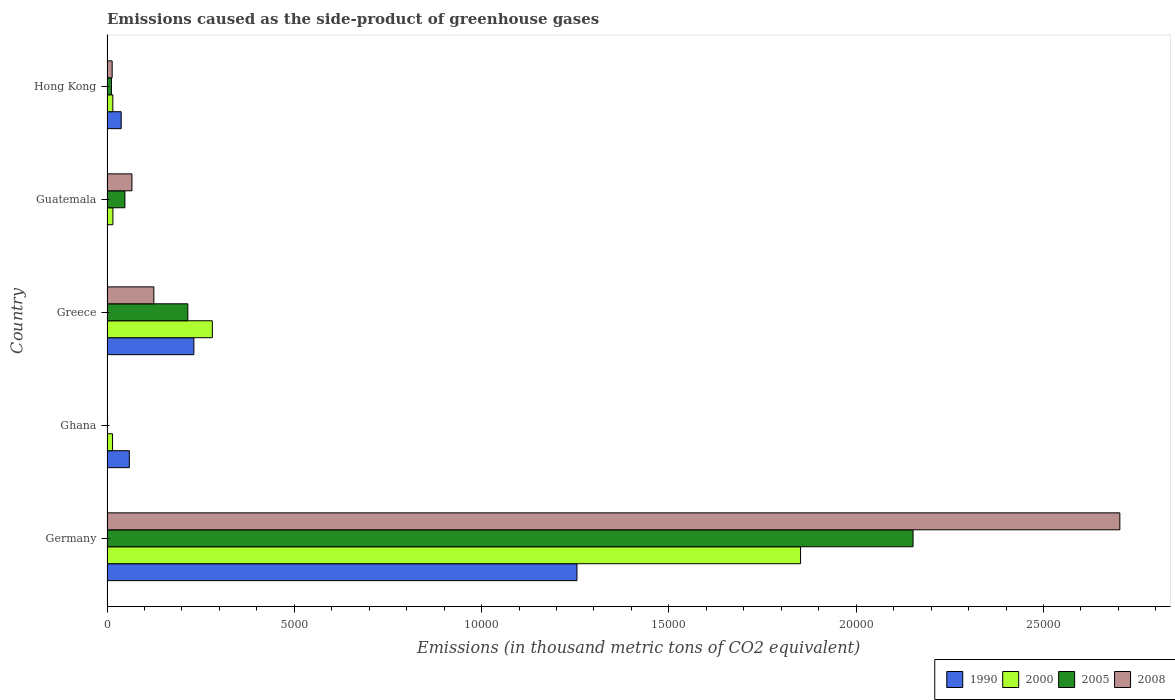How many groups of bars are there?
Give a very brief answer. 5. Are the number of bars on each tick of the Y-axis equal?
Ensure brevity in your answer.  Yes. How many bars are there on the 5th tick from the top?
Ensure brevity in your answer.  4. How many bars are there on the 4th tick from the bottom?
Make the answer very short. 4. What is the label of the 3rd group of bars from the top?
Offer a very short reply. Greece. What is the emissions caused as the side-product of greenhouse gases in 2005 in Hong Kong?
Make the answer very short. 119. Across all countries, what is the maximum emissions caused as the side-product of greenhouse gases in 2008?
Offer a terse response. 2.70e+04. In which country was the emissions caused as the side-product of greenhouse gases in 2008 minimum?
Offer a terse response. Ghana. What is the total emissions caused as the side-product of greenhouse gases in 2000 in the graph?
Make the answer very short. 2.18e+04. What is the difference between the emissions caused as the side-product of greenhouse gases in 2000 in Germany and that in Ghana?
Provide a succinct answer. 1.84e+04. What is the difference between the emissions caused as the side-product of greenhouse gases in 2000 in Guatemala and the emissions caused as the side-product of greenhouse gases in 2008 in Germany?
Provide a short and direct response. -2.69e+04. What is the average emissions caused as the side-product of greenhouse gases in 2005 per country?
Your response must be concise. 4857.2. What is the difference between the emissions caused as the side-product of greenhouse gases in 2005 and emissions caused as the side-product of greenhouse gases in 2008 in Guatemala?
Offer a terse response. -188. In how many countries, is the emissions caused as the side-product of greenhouse gases in 2008 greater than 1000 thousand metric tons?
Offer a terse response. 2. What is the ratio of the emissions caused as the side-product of greenhouse gases in 1990 in Greece to that in Guatemala?
Make the answer very short. 2.32e+04. Is the difference between the emissions caused as the side-product of greenhouse gases in 2005 in Germany and Guatemala greater than the difference between the emissions caused as the side-product of greenhouse gases in 2008 in Germany and Guatemala?
Offer a very short reply. No. What is the difference between the highest and the second highest emissions caused as the side-product of greenhouse gases in 2000?
Your answer should be compact. 1.57e+04. What is the difference between the highest and the lowest emissions caused as the side-product of greenhouse gases in 1990?
Ensure brevity in your answer.  1.25e+04. In how many countries, is the emissions caused as the side-product of greenhouse gases in 1990 greater than the average emissions caused as the side-product of greenhouse gases in 1990 taken over all countries?
Your answer should be compact. 1. Is it the case that in every country, the sum of the emissions caused as the side-product of greenhouse gases in 1990 and emissions caused as the side-product of greenhouse gases in 2005 is greater than the sum of emissions caused as the side-product of greenhouse gases in 2000 and emissions caused as the side-product of greenhouse gases in 2008?
Provide a succinct answer. No. What does the 2nd bar from the top in Ghana represents?
Your answer should be very brief. 2005. What does the 3rd bar from the bottom in Greece represents?
Give a very brief answer. 2005. How many bars are there?
Give a very brief answer. 20. Are all the bars in the graph horizontal?
Your answer should be very brief. Yes. Are the values on the major ticks of X-axis written in scientific E-notation?
Keep it short and to the point. No. Does the graph contain any zero values?
Ensure brevity in your answer.  No. Does the graph contain grids?
Your answer should be very brief. No. What is the title of the graph?
Offer a terse response. Emissions caused as the side-product of greenhouse gases. What is the label or title of the X-axis?
Make the answer very short. Emissions (in thousand metric tons of CO2 equivalent). What is the label or title of the Y-axis?
Offer a very short reply. Country. What is the Emissions (in thousand metric tons of CO2 equivalent) in 1990 in Germany?
Your answer should be compact. 1.25e+04. What is the Emissions (in thousand metric tons of CO2 equivalent) of 2000 in Germany?
Give a very brief answer. 1.85e+04. What is the Emissions (in thousand metric tons of CO2 equivalent) in 2005 in Germany?
Your answer should be very brief. 2.15e+04. What is the Emissions (in thousand metric tons of CO2 equivalent) of 2008 in Germany?
Make the answer very short. 2.70e+04. What is the Emissions (in thousand metric tons of CO2 equivalent) in 1990 in Ghana?
Give a very brief answer. 596.2. What is the Emissions (in thousand metric tons of CO2 equivalent) in 2000 in Ghana?
Make the answer very short. 148. What is the Emissions (in thousand metric tons of CO2 equivalent) in 2008 in Ghana?
Offer a terse response. 11.2. What is the Emissions (in thousand metric tons of CO2 equivalent) of 1990 in Greece?
Make the answer very short. 2318.5. What is the Emissions (in thousand metric tons of CO2 equivalent) of 2000 in Greece?
Your answer should be very brief. 2811.5. What is the Emissions (in thousand metric tons of CO2 equivalent) in 2005 in Greece?
Provide a short and direct response. 2157. What is the Emissions (in thousand metric tons of CO2 equivalent) in 2008 in Greece?
Provide a short and direct response. 1250.2. What is the Emissions (in thousand metric tons of CO2 equivalent) of 2000 in Guatemala?
Offer a terse response. 157.6. What is the Emissions (in thousand metric tons of CO2 equivalent) of 2005 in Guatemala?
Ensure brevity in your answer.  477.8. What is the Emissions (in thousand metric tons of CO2 equivalent) in 2008 in Guatemala?
Provide a succinct answer. 665.8. What is the Emissions (in thousand metric tons of CO2 equivalent) of 1990 in Hong Kong?
Your answer should be very brief. 379. What is the Emissions (in thousand metric tons of CO2 equivalent) of 2000 in Hong Kong?
Give a very brief answer. 155.3. What is the Emissions (in thousand metric tons of CO2 equivalent) in 2005 in Hong Kong?
Provide a succinct answer. 119. What is the Emissions (in thousand metric tons of CO2 equivalent) in 2008 in Hong Kong?
Give a very brief answer. 137.4. Across all countries, what is the maximum Emissions (in thousand metric tons of CO2 equivalent) of 1990?
Offer a terse response. 1.25e+04. Across all countries, what is the maximum Emissions (in thousand metric tons of CO2 equivalent) of 2000?
Ensure brevity in your answer.  1.85e+04. Across all countries, what is the maximum Emissions (in thousand metric tons of CO2 equivalent) in 2005?
Provide a short and direct response. 2.15e+04. Across all countries, what is the maximum Emissions (in thousand metric tons of CO2 equivalent) in 2008?
Give a very brief answer. 2.70e+04. Across all countries, what is the minimum Emissions (in thousand metric tons of CO2 equivalent) of 1990?
Provide a short and direct response. 0.1. Across all countries, what is the minimum Emissions (in thousand metric tons of CO2 equivalent) in 2000?
Your answer should be compact. 148. What is the total Emissions (in thousand metric tons of CO2 equivalent) in 1990 in the graph?
Offer a very short reply. 1.58e+04. What is the total Emissions (in thousand metric tons of CO2 equivalent) in 2000 in the graph?
Your answer should be very brief. 2.18e+04. What is the total Emissions (in thousand metric tons of CO2 equivalent) in 2005 in the graph?
Offer a very short reply. 2.43e+04. What is the total Emissions (in thousand metric tons of CO2 equivalent) of 2008 in the graph?
Ensure brevity in your answer.  2.91e+04. What is the difference between the Emissions (in thousand metric tons of CO2 equivalent) in 1990 in Germany and that in Ghana?
Give a very brief answer. 1.19e+04. What is the difference between the Emissions (in thousand metric tons of CO2 equivalent) in 2000 in Germany and that in Ghana?
Your answer should be compact. 1.84e+04. What is the difference between the Emissions (in thousand metric tons of CO2 equivalent) of 2005 in Germany and that in Ghana?
Your answer should be compact. 2.15e+04. What is the difference between the Emissions (in thousand metric tons of CO2 equivalent) of 2008 in Germany and that in Ghana?
Provide a succinct answer. 2.70e+04. What is the difference between the Emissions (in thousand metric tons of CO2 equivalent) in 1990 in Germany and that in Greece?
Your answer should be compact. 1.02e+04. What is the difference between the Emissions (in thousand metric tons of CO2 equivalent) of 2000 in Germany and that in Greece?
Provide a succinct answer. 1.57e+04. What is the difference between the Emissions (in thousand metric tons of CO2 equivalent) of 2005 in Germany and that in Greece?
Make the answer very short. 1.94e+04. What is the difference between the Emissions (in thousand metric tons of CO2 equivalent) in 2008 in Germany and that in Greece?
Provide a succinct answer. 2.58e+04. What is the difference between the Emissions (in thousand metric tons of CO2 equivalent) of 1990 in Germany and that in Guatemala?
Your answer should be very brief. 1.25e+04. What is the difference between the Emissions (in thousand metric tons of CO2 equivalent) of 2000 in Germany and that in Guatemala?
Provide a succinct answer. 1.84e+04. What is the difference between the Emissions (in thousand metric tons of CO2 equivalent) of 2005 in Germany and that in Guatemala?
Offer a very short reply. 2.10e+04. What is the difference between the Emissions (in thousand metric tons of CO2 equivalent) in 2008 in Germany and that in Guatemala?
Your response must be concise. 2.64e+04. What is the difference between the Emissions (in thousand metric tons of CO2 equivalent) in 1990 in Germany and that in Hong Kong?
Make the answer very short. 1.22e+04. What is the difference between the Emissions (in thousand metric tons of CO2 equivalent) in 2000 in Germany and that in Hong Kong?
Your answer should be compact. 1.84e+04. What is the difference between the Emissions (in thousand metric tons of CO2 equivalent) in 2005 in Germany and that in Hong Kong?
Your answer should be compact. 2.14e+04. What is the difference between the Emissions (in thousand metric tons of CO2 equivalent) in 2008 in Germany and that in Hong Kong?
Make the answer very short. 2.69e+04. What is the difference between the Emissions (in thousand metric tons of CO2 equivalent) in 1990 in Ghana and that in Greece?
Provide a short and direct response. -1722.3. What is the difference between the Emissions (in thousand metric tons of CO2 equivalent) of 2000 in Ghana and that in Greece?
Keep it short and to the point. -2663.5. What is the difference between the Emissions (in thousand metric tons of CO2 equivalent) of 2005 in Ghana and that in Greece?
Provide a succinct answer. -2142.3. What is the difference between the Emissions (in thousand metric tons of CO2 equivalent) of 2008 in Ghana and that in Greece?
Your answer should be very brief. -1239. What is the difference between the Emissions (in thousand metric tons of CO2 equivalent) in 1990 in Ghana and that in Guatemala?
Ensure brevity in your answer.  596.1. What is the difference between the Emissions (in thousand metric tons of CO2 equivalent) in 2005 in Ghana and that in Guatemala?
Your answer should be very brief. -463.1. What is the difference between the Emissions (in thousand metric tons of CO2 equivalent) in 2008 in Ghana and that in Guatemala?
Provide a succinct answer. -654.6. What is the difference between the Emissions (in thousand metric tons of CO2 equivalent) in 1990 in Ghana and that in Hong Kong?
Ensure brevity in your answer.  217.2. What is the difference between the Emissions (in thousand metric tons of CO2 equivalent) of 2005 in Ghana and that in Hong Kong?
Your answer should be compact. -104.3. What is the difference between the Emissions (in thousand metric tons of CO2 equivalent) in 2008 in Ghana and that in Hong Kong?
Your response must be concise. -126.2. What is the difference between the Emissions (in thousand metric tons of CO2 equivalent) of 1990 in Greece and that in Guatemala?
Offer a very short reply. 2318.4. What is the difference between the Emissions (in thousand metric tons of CO2 equivalent) of 2000 in Greece and that in Guatemala?
Keep it short and to the point. 2653.9. What is the difference between the Emissions (in thousand metric tons of CO2 equivalent) of 2005 in Greece and that in Guatemala?
Ensure brevity in your answer.  1679.2. What is the difference between the Emissions (in thousand metric tons of CO2 equivalent) in 2008 in Greece and that in Guatemala?
Make the answer very short. 584.4. What is the difference between the Emissions (in thousand metric tons of CO2 equivalent) of 1990 in Greece and that in Hong Kong?
Your answer should be very brief. 1939.5. What is the difference between the Emissions (in thousand metric tons of CO2 equivalent) of 2000 in Greece and that in Hong Kong?
Make the answer very short. 2656.2. What is the difference between the Emissions (in thousand metric tons of CO2 equivalent) of 2005 in Greece and that in Hong Kong?
Keep it short and to the point. 2038. What is the difference between the Emissions (in thousand metric tons of CO2 equivalent) of 2008 in Greece and that in Hong Kong?
Your answer should be very brief. 1112.8. What is the difference between the Emissions (in thousand metric tons of CO2 equivalent) in 1990 in Guatemala and that in Hong Kong?
Your response must be concise. -378.9. What is the difference between the Emissions (in thousand metric tons of CO2 equivalent) of 2005 in Guatemala and that in Hong Kong?
Provide a succinct answer. 358.8. What is the difference between the Emissions (in thousand metric tons of CO2 equivalent) of 2008 in Guatemala and that in Hong Kong?
Provide a short and direct response. 528.4. What is the difference between the Emissions (in thousand metric tons of CO2 equivalent) in 1990 in Germany and the Emissions (in thousand metric tons of CO2 equivalent) in 2000 in Ghana?
Give a very brief answer. 1.24e+04. What is the difference between the Emissions (in thousand metric tons of CO2 equivalent) of 1990 in Germany and the Emissions (in thousand metric tons of CO2 equivalent) of 2005 in Ghana?
Your answer should be very brief. 1.25e+04. What is the difference between the Emissions (in thousand metric tons of CO2 equivalent) of 1990 in Germany and the Emissions (in thousand metric tons of CO2 equivalent) of 2008 in Ghana?
Your answer should be very brief. 1.25e+04. What is the difference between the Emissions (in thousand metric tons of CO2 equivalent) of 2000 in Germany and the Emissions (in thousand metric tons of CO2 equivalent) of 2005 in Ghana?
Give a very brief answer. 1.85e+04. What is the difference between the Emissions (in thousand metric tons of CO2 equivalent) in 2000 in Germany and the Emissions (in thousand metric tons of CO2 equivalent) in 2008 in Ghana?
Your answer should be compact. 1.85e+04. What is the difference between the Emissions (in thousand metric tons of CO2 equivalent) in 2005 in Germany and the Emissions (in thousand metric tons of CO2 equivalent) in 2008 in Ghana?
Provide a succinct answer. 2.15e+04. What is the difference between the Emissions (in thousand metric tons of CO2 equivalent) of 1990 in Germany and the Emissions (in thousand metric tons of CO2 equivalent) of 2000 in Greece?
Provide a succinct answer. 9734.2. What is the difference between the Emissions (in thousand metric tons of CO2 equivalent) in 1990 in Germany and the Emissions (in thousand metric tons of CO2 equivalent) in 2005 in Greece?
Ensure brevity in your answer.  1.04e+04. What is the difference between the Emissions (in thousand metric tons of CO2 equivalent) of 1990 in Germany and the Emissions (in thousand metric tons of CO2 equivalent) of 2008 in Greece?
Your response must be concise. 1.13e+04. What is the difference between the Emissions (in thousand metric tons of CO2 equivalent) of 2000 in Germany and the Emissions (in thousand metric tons of CO2 equivalent) of 2005 in Greece?
Your answer should be compact. 1.64e+04. What is the difference between the Emissions (in thousand metric tons of CO2 equivalent) in 2000 in Germany and the Emissions (in thousand metric tons of CO2 equivalent) in 2008 in Greece?
Keep it short and to the point. 1.73e+04. What is the difference between the Emissions (in thousand metric tons of CO2 equivalent) in 2005 in Germany and the Emissions (in thousand metric tons of CO2 equivalent) in 2008 in Greece?
Offer a terse response. 2.03e+04. What is the difference between the Emissions (in thousand metric tons of CO2 equivalent) of 1990 in Germany and the Emissions (in thousand metric tons of CO2 equivalent) of 2000 in Guatemala?
Make the answer very short. 1.24e+04. What is the difference between the Emissions (in thousand metric tons of CO2 equivalent) in 1990 in Germany and the Emissions (in thousand metric tons of CO2 equivalent) in 2005 in Guatemala?
Provide a short and direct response. 1.21e+04. What is the difference between the Emissions (in thousand metric tons of CO2 equivalent) of 1990 in Germany and the Emissions (in thousand metric tons of CO2 equivalent) of 2008 in Guatemala?
Your response must be concise. 1.19e+04. What is the difference between the Emissions (in thousand metric tons of CO2 equivalent) in 2000 in Germany and the Emissions (in thousand metric tons of CO2 equivalent) in 2005 in Guatemala?
Your response must be concise. 1.80e+04. What is the difference between the Emissions (in thousand metric tons of CO2 equivalent) in 2000 in Germany and the Emissions (in thousand metric tons of CO2 equivalent) in 2008 in Guatemala?
Ensure brevity in your answer.  1.78e+04. What is the difference between the Emissions (in thousand metric tons of CO2 equivalent) of 2005 in Germany and the Emissions (in thousand metric tons of CO2 equivalent) of 2008 in Guatemala?
Your answer should be very brief. 2.09e+04. What is the difference between the Emissions (in thousand metric tons of CO2 equivalent) of 1990 in Germany and the Emissions (in thousand metric tons of CO2 equivalent) of 2000 in Hong Kong?
Your response must be concise. 1.24e+04. What is the difference between the Emissions (in thousand metric tons of CO2 equivalent) in 1990 in Germany and the Emissions (in thousand metric tons of CO2 equivalent) in 2005 in Hong Kong?
Keep it short and to the point. 1.24e+04. What is the difference between the Emissions (in thousand metric tons of CO2 equivalent) of 1990 in Germany and the Emissions (in thousand metric tons of CO2 equivalent) of 2008 in Hong Kong?
Keep it short and to the point. 1.24e+04. What is the difference between the Emissions (in thousand metric tons of CO2 equivalent) of 2000 in Germany and the Emissions (in thousand metric tons of CO2 equivalent) of 2005 in Hong Kong?
Provide a succinct answer. 1.84e+04. What is the difference between the Emissions (in thousand metric tons of CO2 equivalent) in 2000 in Germany and the Emissions (in thousand metric tons of CO2 equivalent) in 2008 in Hong Kong?
Offer a very short reply. 1.84e+04. What is the difference between the Emissions (in thousand metric tons of CO2 equivalent) of 2005 in Germany and the Emissions (in thousand metric tons of CO2 equivalent) of 2008 in Hong Kong?
Provide a short and direct response. 2.14e+04. What is the difference between the Emissions (in thousand metric tons of CO2 equivalent) of 1990 in Ghana and the Emissions (in thousand metric tons of CO2 equivalent) of 2000 in Greece?
Ensure brevity in your answer.  -2215.3. What is the difference between the Emissions (in thousand metric tons of CO2 equivalent) in 1990 in Ghana and the Emissions (in thousand metric tons of CO2 equivalent) in 2005 in Greece?
Offer a very short reply. -1560.8. What is the difference between the Emissions (in thousand metric tons of CO2 equivalent) of 1990 in Ghana and the Emissions (in thousand metric tons of CO2 equivalent) of 2008 in Greece?
Your answer should be compact. -654. What is the difference between the Emissions (in thousand metric tons of CO2 equivalent) of 2000 in Ghana and the Emissions (in thousand metric tons of CO2 equivalent) of 2005 in Greece?
Ensure brevity in your answer.  -2009. What is the difference between the Emissions (in thousand metric tons of CO2 equivalent) in 2000 in Ghana and the Emissions (in thousand metric tons of CO2 equivalent) in 2008 in Greece?
Provide a succinct answer. -1102.2. What is the difference between the Emissions (in thousand metric tons of CO2 equivalent) of 2005 in Ghana and the Emissions (in thousand metric tons of CO2 equivalent) of 2008 in Greece?
Provide a short and direct response. -1235.5. What is the difference between the Emissions (in thousand metric tons of CO2 equivalent) of 1990 in Ghana and the Emissions (in thousand metric tons of CO2 equivalent) of 2000 in Guatemala?
Provide a succinct answer. 438.6. What is the difference between the Emissions (in thousand metric tons of CO2 equivalent) in 1990 in Ghana and the Emissions (in thousand metric tons of CO2 equivalent) in 2005 in Guatemala?
Your response must be concise. 118.4. What is the difference between the Emissions (in thousand metric tons of CO2 equivalent) of 1990 in Ghana and the Emissions (in thousand metric tons of CO2 equivalent) of 2008 in Guatemala?
Provide a short and direct response. -69.6. What is the difference between the Emissions (in thousand metric tons of CO2 equivalent) in 2000 in Ghana and the Emissions (in thousand metric tons of CO2 equivalent) in 2005 in Guatemala?
Provide a succinct answer. -329.8. What is the difference between the Emissions (in thousand metric tons of CO2 equivalent) of 2000 in Ghana and the Emissions (in thousand metric tons of CO2 equivalent) of 2008 in Guatemala?
Make the answer very short. -517.8. What is the difference between the Emissions (in thousand metric tons of CO2 equivalent) of 2005 in Ghana and the Emissions (in thousand metric tons of CO2 equivalent) of 2008 in Guatemala?
Provide a succinct answer. -651.1. What is the difference between the Emissions (in thousand metric tons of CO2 equivalent) in 1990 in Ghana and the Emissions (in thousand metric tons of CO2 equivalent) in 2000 in Hong Kong?
Ensure brevity in your answer.  440.9. What is the difference between the Emissions (in thousand metric tons of CO2 equivalent) in 1990 in Ghana and the Emissions (in thousand metric tons of CO2 equivalent) in 2005 in Hong Kong?
Your answer should be very brief. 477.2. What is the difference between the Emissions (in thousand metric tons of CO2 equivalent) in 1990 in Ghana and the Emissions (in thousand metric tons of CO2 equivalent) in 2008 in Hong Kong?
Offer a very short reply. 458.8. What is the difference between the Emissions (in thousand metric tons of CO2 equivalent) of 2000 in Ghana and the Emissions (in thousand metric tons of CO2 equivalent) of 2005 in Hong Kong?
Make the answer very short. 29. What is the difference between the Emissions (in thousand metric tons of CO2 equivalent) of 2005 in Ghana and the Emissions (in thousand metric tons of CO2 equivalent) of 2008 in Hong Kong?
Provide a succinct answer. -122.7. What is the difference between the Emissions (in thousand metric tons of CO2 equivalent) in 1990 in Greece and the Emissions (in thousand metric tons of CO2 equivalent) in 2000 in Guatemala?
Your response must be concise. 2160.9. What is the difference between the Emissions (in thousand metric tons of CO2 equivalent) in 1990 in Greece and the Emissions (in thousand metric tons of CO2 equivalent) in 2005 in Guatemala?
Give a very brief answer. 1840.7. What is the difference between the Emissions (in thousand metric tons of CO2 equivalent) in 1990 in Greece and the Emissions (in thousand metric tons of CO2 equivalent) in 2008 in Guatemala?
Offer a very short reply. 1652.7. What is the difference between the Emissions (in thousand metric tons of CO2 equivalent) in 2000 in Greece and the Emissions (in thousand metric tons of CO2 equivalent) in 2005 in Guatemala?
Your answer should be very brief. 2333.7. What is the difference between the Emissions (in thousand metric tons of CO2 equivalent) of 2000 in Greece and the Emissions (in thousand metric tons of CO2 equivalent) of 2008 in Guatemala?
Make the answer very short. 2145.7. What is the difference between the Emissions (in thousand metric tons of CO2 equivalent) of 2005 in Greece and the Emissions (in thousand metric tons of CO2 equivalent) of 2008 in Guatemala?
Keep it short and to the point. 1491.2. What is the difference between the Emissions (in thousand metric tons of CO2 equivalent) in 1990 in Greece and the Emissions (in thousand metric tons of CO2 equivalent) in 2000 in Hong Kong?
Your answer should be compact. 2163.2. What is the difference between the Emissions (in thousand metric tons of CO2 equivalent) in 1990 in Greece and the Emissions (in thousand metric tons of CO2 equivalent) in 2005 in Hong Kong?
Make the answer very short. 2199.5. What is the difference between the Emissions (in thousand metric tons of CO2 equivalent) of 1990 in Greece and the Emissions (in thousand metric tons of CO2 equivalent) of 2008 in Hong Kong?
Your answer should be very brief. 2181.1. What is the difference between the Emissions (in thousand metric tons of CO2 equivalent) of 2000 in Greece and the Emissions (in thousand metric tons of CO2 equivalent) of 2005 in Hong Kong?
Ensure brevity in your answer.  2692.5. What is the difference between the Emissions (in thousand metric tons of CO2 equivalent) of 2000 in Greece and the Emissions (in thousand metric tons of CO2 equivalent) of 2008 in Hong Kong?
Keep it short and to the point. 2674.1. What is the difference between the Emissions (in thousand metric tons of CO2 equivalent) in 2005 in Greece and the Emissions (in thousand metric tons of CO2 equivalent) in 2008 in Hong Kong?
Ensure brevity in your answer.  2019.6. What is the difference between the Emissions (in thousand metric tons of CO2 equivalent) in 1990 in Guatemala and the Emissions (in thousand metric tons of CO2 equivalent) in 2000 in Hong Kong?
Your answer should be very brief. -155.2. What is the difference between the Emissions (in thousand metric tons of CO2 equivalent) in 1990 in Guatemala and the Emissions (in thousand metric tons of CO2 equivalent) in 2005 in Hong Kong?
Give a very brief answer. -118.9. What is the difference between the Emissions (in thousand metric tons of CO2 equivalent) of 1990 in Guatemala and the Emissions (in thousand metric tons of CO2 equivalent) of 2008 in Hong Kong?
Your response must be concise. -137.3. What is the difference between the Emissions (in thousand metric tons of CO2 equivalent) in 2000 in Guatemala and the Emissions (in thousand metric tons of CO2 equivalent) in 2005 in Hong Kong?
Offer a very short reply. 38.6. What is the difference between the Emissions (in thousand metric tons of CO2 equivalent) in 2000 in Guatemala and the Emissions (in thousand metric tons of CO2 equivalent) in 2008 in Hong Kong?
Your answer should be very brief. 20.2. What is the difference between the Emissions (in thousand metric tons of CO2 equivalent) in 2005 in Guatemala and the Emissions (in thousand metric tons of CO2 equivalent) in 2008 in Hong Kong?
Provide a short and direct response. 340.4. What is the average Emissions (in thousand metric tons of CO2 equivalent) in 1990 per country?
Give a very brief answer. 3167.9. What is the average Emissions (in thousand metric tons of CO2 equivalent) in 2000 per country?
Your answer should be compact. 4357.26. What is the average Emissions (in thousand metric tons of CO2 equivalent) of 2005 per country?
Your response must be concise. 4857.2. What is the average Emissions (in thousand metric tons of CO2 equivalent) in 2008 per country?
Your answer should be compact. 5820.48. What is the difference between the Emissions (in thousand metric tons of CO2 equivalent) of 1990 and Emissions (in thousand metric tons of CO2 equivalent) of 2000 in Germany?
Your answer should be very brief. -5968.2. What is the difference between the Emissions (in thousand metric tons of CO2 equivalent) of 1990 and Emissions (in thousand metric tons of CO2 equivalent) of 2005 in Germany?
Ensure brevity in your answer.  -8971.8. What is the difference between the Emissions (in thousand metric tons of CO2 equivalent) in 1990 and Emissions (in thousand metric tons of CO2 equivalent) in 2008 in Germany?
Offer a terse response. -1.45e+04. What is the difference between the Emissions (in thousand metric tons of CO2 equivalent) of 2000 and Emissions (in thousand metric tons of CO2 equivalent) of 2005 in Germany?
Offer a terse response. -3003.6. What is the difference between the Emissions (in thousand metric tons of CO2 equivalent) of 2000 and Emissions (in thousand metric tons of CO2 equivalent) of 2008 in Germany?
Your answer should be very brief. -8523.9. What is the difference between the Emissions (in thousand metric tons of CO2 equivalent) in 2005 and Emissions (in thousand metric tons of CO2 equivalent) in 2008 in Germany?
Ensure brevity in your answer.  -5520.3. What is the difference between the Emissions (in thousand metric tons of CO2 equivalent) in 1990 and Emissions (in thousand metric tons of CO2 equivalent) in 2000 in Ghana?
Keep it short and to the point. 448.2. What is the difference between the Emissions (in thousand metric tons of CO2 equivalent) in 1990 and Emissions (in thousand metric tons of CO2 equivalent) in 2005 in Ghana?
Make the answer very short. 581.5. What is the difference between the Emissions (in thousand metric tons of CO2 equivalent) of 1990 and Emissions (in thousand metric tons of CO2 equivalent) of 2008 in Ghana?
Keep it short and to the point. 585. What is the difference between the Emissions (in thousand metric tons of CO2 equivalent) in 2000 and Emissions (in thousand metric tons of CO2 equivalent) in 2005 in Ghana?
Offer a terse response. 133.3. What is the difference between the Emissions (in thousand metric tons of CO2 equivalent) in 2000 and Emissions (in thousand metric tons of CO2 equivalent) in 2008 in Ghana?
Offer a terse response. 136.8. What is the difference between the Emissions (in thousand metric tons of CO2 equivalent) of 2005 and Emissions (in thousand metric tons of CO2 equivalent) of 2008 in Ghana?
Give a very brief answer. 3.5. What is the difference between the Emissions (in thousand metric tons of CO2 equivalent) of 1990 and Emissions (in thousand metric tons of CO2 equivalent) of 2000 in Greece?
Make the answer very short. -493. What is the difference between the Emissions (in thousand metric tons of CO2 equivalent) of 1990 and Emissions (in thousand metric tons of CO2 equivalent) of 2005 in Greece?
Your answer should be very brief. 161.5. What is the difference between the Emissions (in thousand metric tons of CO2 equivalent) in 1990 and Emissions (in thousand metric tons of CO2 equivalent) in 2008 in Greece?
Offer a terse response. 1068.3. What is the difference between the Emissions (in thousand metric tons of CO2 equivalent) of 2000 and Emissions (in thousand metric tons of CO2 equivalent) of 2005 in Greece?
Your answer should be compact. 654.5. What is the difference between the Emissions (in thousand metric tons of CO2 equivalent) in 2000 and Emissions (in thousand metric tons of CO2 equivalent) in 2008 in Greece?
Your answer should be compact. 1561.3. What is the difference between the Emissions (in thousand metric tons of CO2 equivalent) in 2005 and Emissions (in thousand metric tons of CO2 equivalent) in 2008 in Greece?
Your answer should be very brief. 906.8. What is the difference between the Emissions (in thousand metric tons of CO2 equivalent) of 1990 and Emissions (in thousand metric tons of CO2 equivalent) of 2000 in Guatemala?
Offer a very short reply. -157.5. What is the difference between the Emissions (in thousand metric tons of CO2 equivalent) of 1990 and Emissions (in thousand metric tons of CO2 equivalent) of 2005 in Guatemala?
Make the answer very short. -477.7. What is the difference between the Emissions (in thousand metric tons of CO2 equivalent) in 1990 and Emissions (in thousand metric tons of CO2 equivalent) in 2008 in Guatemala?
Make the answer very short. -665.7. What is the difference between the Emissions (in thousand metric tons of CO2 equivalent) of 2000 and Emissions (in thousand metric tons of CO2 equivalent) of 2005 in Guatemala?
Your response must be concise. -320.2. What is the difference between the Emissions (in thousand metric tons of CO2 equivalent) in 2000 and Emissions (in thousand metric tons of CO2 equivalent) in 2008 in Guatemala?
Your response must be concise. -508.2. What is the difference between the Emissions (in thousand metric tons of CO2 equivalent) of 2005 and Emissions (in thousand metric tons of CO2 equivalent) of 2008 in Guatemala?
Your answer should be very brief. -188. What is the difference between the Emissions (in thousand metric tons of CO2 equivalent) in 1990 and Emissions (in thousand metric tons of CO2 equivalent) in 2000 in Hong Kong?
Keep it short and to the point. 223.7. What is the difference between the Emissions (in thousand metric tons of CO2 equivalent) of 1990 and Emissions (in thousand metric tons of CO2 equivalent) of 2005 in Hong Kong?
Your answer should be compact. 260. What is the difference between the Emissions (in thousand metric tons of CO2 equivalent) of 1990 and Emissions (in thousand metric tons of CO2 equivalent) of 2008 in Hong Kong?
Ensure brevity in your answer.  241.6. What is the difference between the Emissions (in thousand metric tons of CO2 equivalent) in 2000 and Emissions (in thousand metric tons of CO2 equivalent) in 2005 in Hong Kong?
Provide a succinct answer. 36.3. What is the difference between the Emissions (in thousand metric tons of CO2 equivalent) of 2000 and Emissions (in thousand metric tons of CO2 equivalent) of 2008 in Hong Kong?
Offer a very short reply. 17.9. What is the difference between the Emissions (in thousand metric tons of CO2 equivalent) in 2005 and Emissions (in thousand metric tons of CO2 equivalent) in 2008 in Hong Kong?
Provide a short and direct response. -18.4. What is the ratio of the Emissions (in thousand metric tons of CO2 equivalent) of 1990 in Germany to that in Ghana?
Your answer should be very brief. 21.04. What is the ratio of the Emissions (in thousand metric tons of CO2 equivalent) in 2000 in Germany to that in Ghana?
Provide a succinct answer. 125.09. What is the ratio of the Emissions (in thousand metric tons of CO2 equivalent) in 2005 in Germany to that in Ghana?
Offer a very short reply. 1463.78. What is the ratio of the Emissions (in thousand metric tons of CO2 equivalent) of 2008 in Germany to that in Ghana?
Your answer should be compact. 2414.09. What is the ratio of the Emissions (in thousand metric tons of CO2 equivalent) of 1990 in Germany to that in Greece?
Give a very brief answer. 5.41. What is the ratio of the Emissions (in thousand metric tons of CO2 equivalent) in 2000 in Germany to that in Greece?
Provide a succinct answer. 6.59. What is the ratio of the Emissions (in thousand metric tons of CO2 equivalent) in 2005 in Germany to that in Greece?
Your answer should be compact. 9.98. What is the ratio of the Emissions (in thousand metric tons of CO2 equivalent) in 2008 in Germany to that in Greece?
Keep it short and to the point. 21.63. What is the ratio of the Emissions (in thousand metric tons of CO2 equivalent) of 1990 in Germany to that in Guatemala?
Provide a succinct answer. 1.25e+05. What is the ratio of the Emissions (in thousand metric tons of CO2 equivalent) in 2000 in Germany to that in Guatemala?
Provide a short and direct response. 117.47. What is the ratio of the Emissions (in thousand metric tons of CO2 equivalent) of 2005 in Germany to that in Guatemala?
Provide a succinct answer. 45.03. What is the ratio of the Emissions (in thousand metric tons of CO2 equivalent) of 2008 in Germany to that in Guatemala?
Your answer should be very brief. 40.61. What is the ratio of the Emissions (in thousand metric tons of CO2 equivalent) in 1990 in Germany to that in Hong Kong?
Your answer should be very brief. 33.1. What is the ratio of the Emissions (in thousand metric tons of CO2 equivalent) in 2000 in Germany to that in Hong Kong?
Your answer should be very brief. 119.21. What is the ratio of the Emissions (in thousand metric tons of CO2 equivalent) in 2005 in Germany to that in Hong Kong?
Ensure brevity in your answer.  180.82. What is the ratio of the Emissions (in thousand metric tons of CO2 equivalent) in 2008 in Germany to that in Hong Kong?
Keep it short and to the point. 196.78. What is the ratio of the Emissions (in thousand metric tons of CO2 equivalent) in 1990 in Ghana to that in Greece?
Offer a very short reply. 0.26. What is the ratio of the Emissions (in thousand metric tons of CO2 equivalent) of 2000 in Ghana to that in Greece?
Provide a succinct answer. 0.05. What is the ratio of the Emissions (in thousand metric tons of CO2 equivalent) in 2005 in Ghana to that in Greece?
Keep it short and to the point. 0.01. What is the ratio of the Emissions (in thousand metric tons of CO2 equivalent) in 2008 in Ghana to that in Greece?
Provide a short and direct response. 0.01. What is the ratio of the Emissions (in thousand metric tons of CO2 equivalent) of 1990 in Ghana to that in Guatemala?
Your answer should be very brief. 5962. What is the ratio of the Emissions (in thousand metric tons of CO2 equivalent) in 2000 in Ghana to that in Guatemala?
Provide a short and direct response. 0.94. What is the ratio of the Emissions (in thousand metric tons of CO2 equivalent) in 2005 in Ghana to that in Guatemala?
Make the answer very short. 0.03. What is the ratio of the Emissions (in thousand metric tons of CO2 equivalent) of 2008 in Ghana to that in Guatemala?
Keep it short and to the point. 0.02. What is the ratio of the Emissions (in thousand metric tons of CO2 equivalent) in 1990 in Ghana to that in Hong Kong?
Make the answer very short. 1.57. What is the ratio of the Emissions (in thousand metric tons of CO2 equivalent) in 2000 in Ghana to that in Hong Kong?
Ensure brevity in your answer.  0.95. What is the ratio of the Emissions (in thousand metric tons of CO2 equivalent) of 2005 in Ghana to that in Hong Kong?
Your response must be concise. 0.12. What is the ratio of the Emissions (in thousand metric tons of CO2 equivalent) in 2008 in Ghana to that in Hong Kong?
Offer a terse response. 0.08. What is the ratio of the Emissions (in thousand metric tons of CO2 equivalent) of 1990 in Greece to that in Guatemala?
Provide a short and direct response. 2.32e+04. What is the ratio of the Emissions (in thousand metric tons of CO2 equivalent) in 2000 in Greece to that in Guatemala?
Offer a terse response. 17.84. What is the ratio of the Emissions (in thousand metric tons of CO2 equivalent) in 2005 in Greece to that in Guatemala?
Provide a succinct answer. 4.51. What is the ratio of the Emissions (in thousand metric tons of CO2 equivalent) in 2008 in Greece to that in Guatemala?
Offer a terse response. 1.88. What is the ratio of the Emissions (in thousand metric tons of CO2 equivalent) in 1990 in Greece to that in Hong Kong?
Make the answer very short. 6.12. What is the ratio of the Emissions (in thousand metric tons of CO2 equivalent) in 2000 in Greece to that in Hong Kong?
Provide a short and direct response. 18.1. What is the ratio of the Emissions (in thousand metric tons of CO2 equivalent) of 2005 in Greece to that in Hong Kong?
Your answer should be compact. 18.13. What is the ratio of the Emissions (in thousand metric tons of CO2 equivalent) of 2008 in Greece to that in Hong Kong?
Provide a short and direct response. 9.1. What is the ratio of the Emissions (in thousand metric tons of CO2 equivalent) in 2000 in Guatemala to that in Hong Kong?
Your response must be concise. 1.01. What is the ratio of the Emissions (in thousand metric tons of CO2 equivalent) in 2005 in Guatemala to that in Hong Kong?
Your answer should be compact. 4.02. What is the ratio of the Emissions (in thousand metric tons of CO2 equivalent) in 2008 in Guatemala to that in Hong Kong?
Keep it short and to the point. 4.85. What is the difference between the highest and the second highest Emissions (in thousand metric tons of CO2 equivalent) in 1990?
Give a very brief answer. 1.02e+04. What is the difference between the highest and the second highest Emissions (in thousand metric tons of CO2 equivalent) of 2000?
Ensure brevity in your answer.  1.57e+04. What is the difference between the highest and the second highest Emissions (in thousand metric tons of CO2 equivalent) in 2005?
Offer a terse response. 1.94e+04. What is the difference between the highest and the second highest Emissions (in thousand metric tons of CO2 equivalent) of 2008?
Ensure brevity in your answer.  2.58e+04. What is the difference between the highest and the lowest Emissions (in thousand metric tons of CO2 equivalent) in 1990?
Your answer should be very brief. 1.25e+04. What is the difference between the highest and the lowest Emissions (in thousand metric tons of CO2 equivalent) of 2000?
Your answer should be compact. 1.84e+04. What is the difference between the highest and the lowest Emissions (in thousand metric tons of CO2 equivalent) in 2005?
Your answer should be compact. 2.15e+04. What is the difference between the highest and the lowest Emissions (in thousand metric tons of CO2 equivalent) in 2008?
Offer a very short reply. 2.70e+04. 